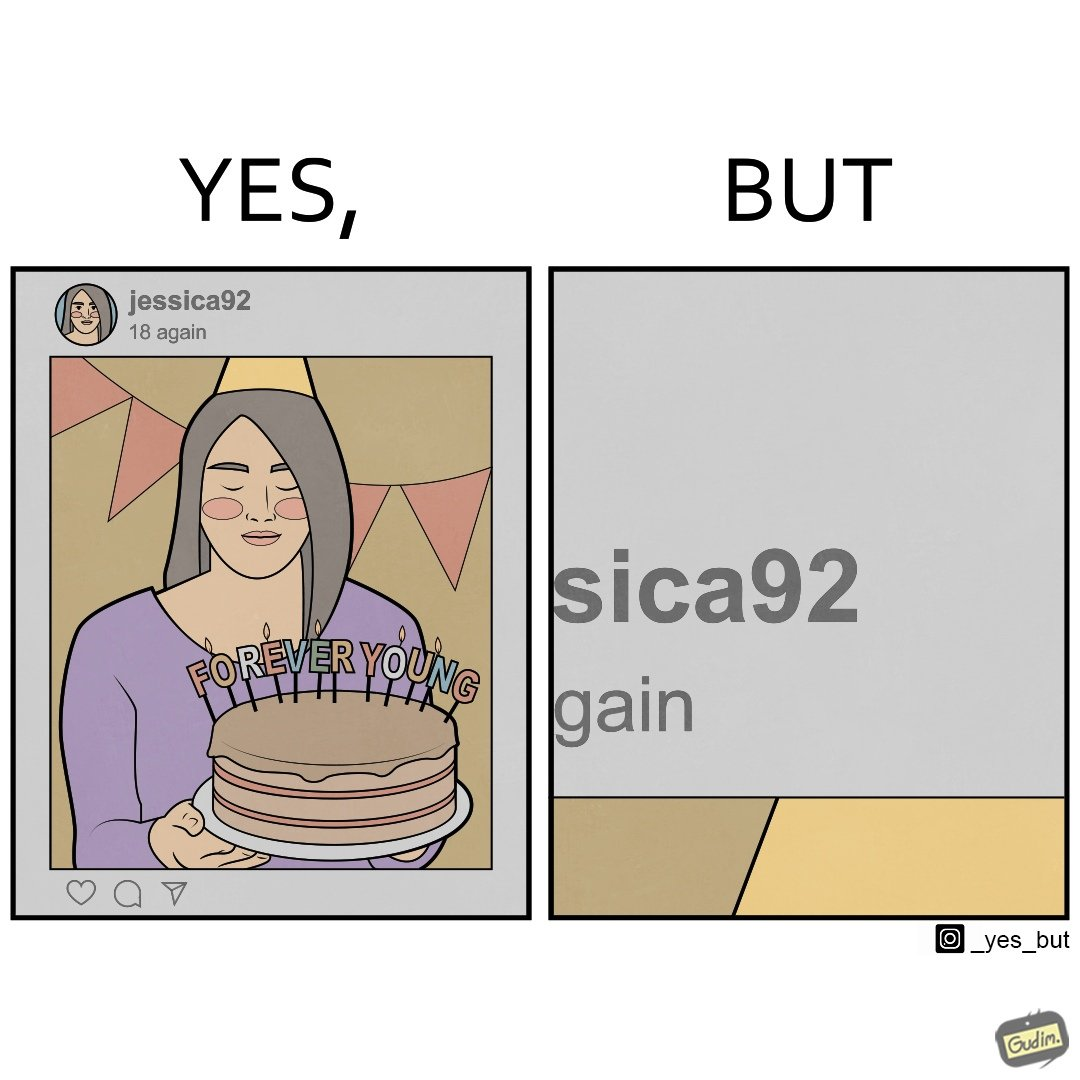Explain the humor or irony in this image. The image is funny because while the woman claims she to be young, the likely year of her birth 1992 which can be inferred from her handle "jessica92" suggests that she is very old. 